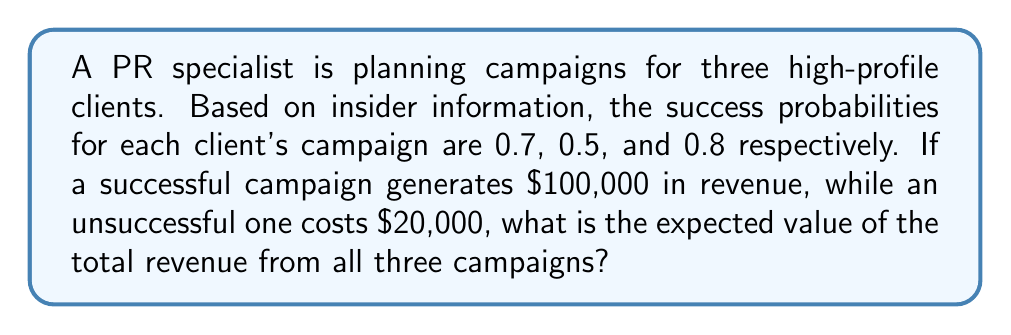Can you answer this question? Let's approach this step-by-step:

1) First, we need to calculate the expected value for each campaign.

2) For Client 1:
   $E_1 = 0.7 \cdot \$100,000 + 0.3 \cdot (-\$20,000)$
   $E_1 = \$70,000 - \$6,000 = \$64,000$

3) For Client 2:
   $E_2 = 0.5 \cdot \$100,000 + 0.5 \cdot (-\$20,000)$
   $E_2 = \$50,000 - \$10,000 = \$40,000$

4) For Client 3:
   $E_3 = 0.8 \cdot \$100,000 + 0.2 \cdot (-\$20,000)$
   $E_3 = \$80,000 - \$4,000 = \$76,000$

5) The total expected value is the sum of these individual expected values:

   $E_{total} = E_1 + E_2 + E_3$
   $E_{total} = \$64,000 + \$40,000 + \$76,000 = \$180,000$

Therefore, the expected value of the total revenue from all three campaigns is $180,000.
Answer: $180,000 